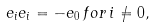Convert formula to latex. <formula><loc_0><loc_0><loc_500><loc_500>e _ { i } e _ { i } = - e _ { 0 } \, { f o r } \, i \neq 0 ,</formula> 